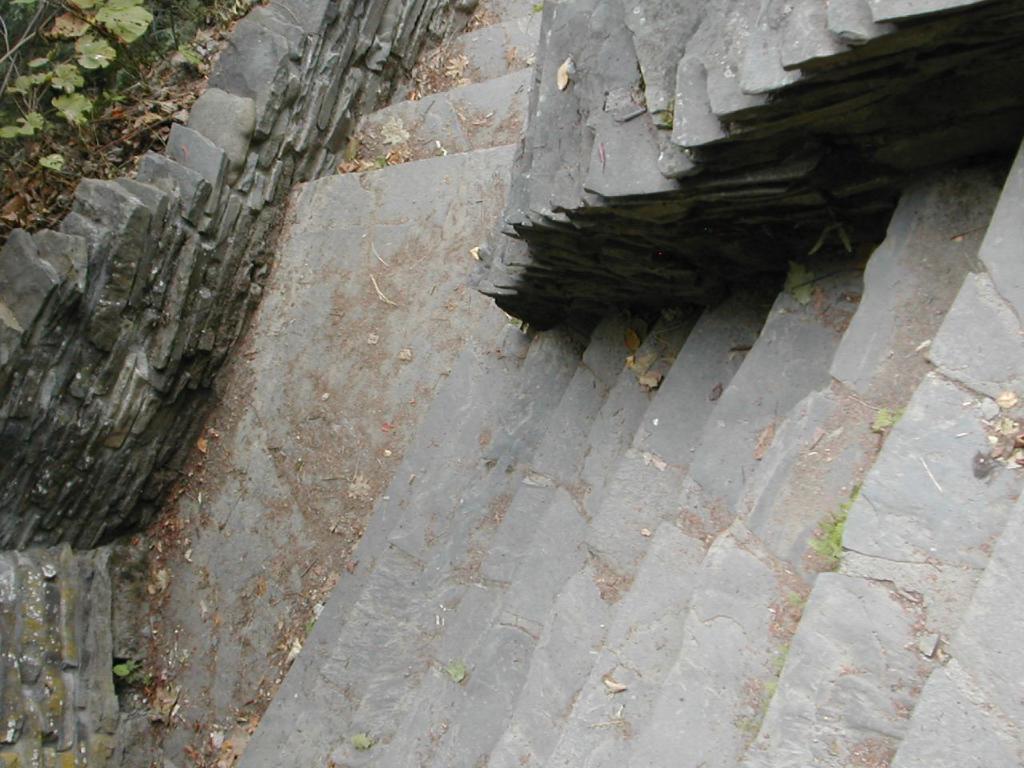Please provide a concise description of this image. Here in this picture we can see steps present over a place and on the left top side we can see plants and dry leaves present on the ground. 